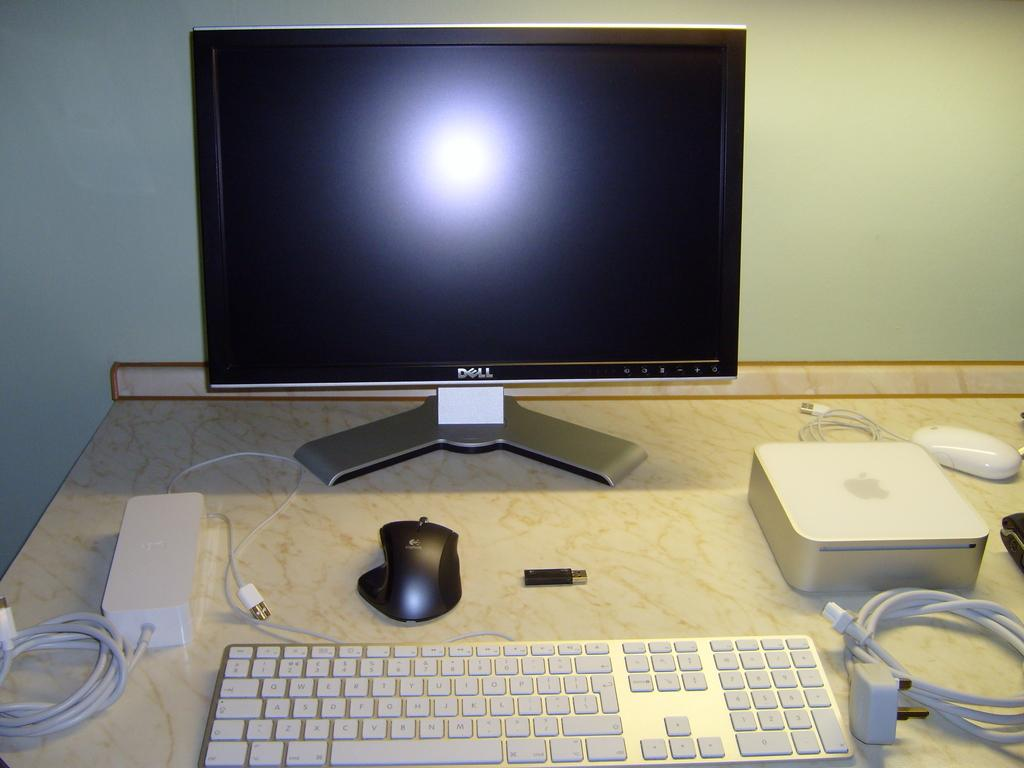<image>
Offer a succinct explanation of the picture presented. A dell computer monitor along with a keyboard, mouse, and other cords. 